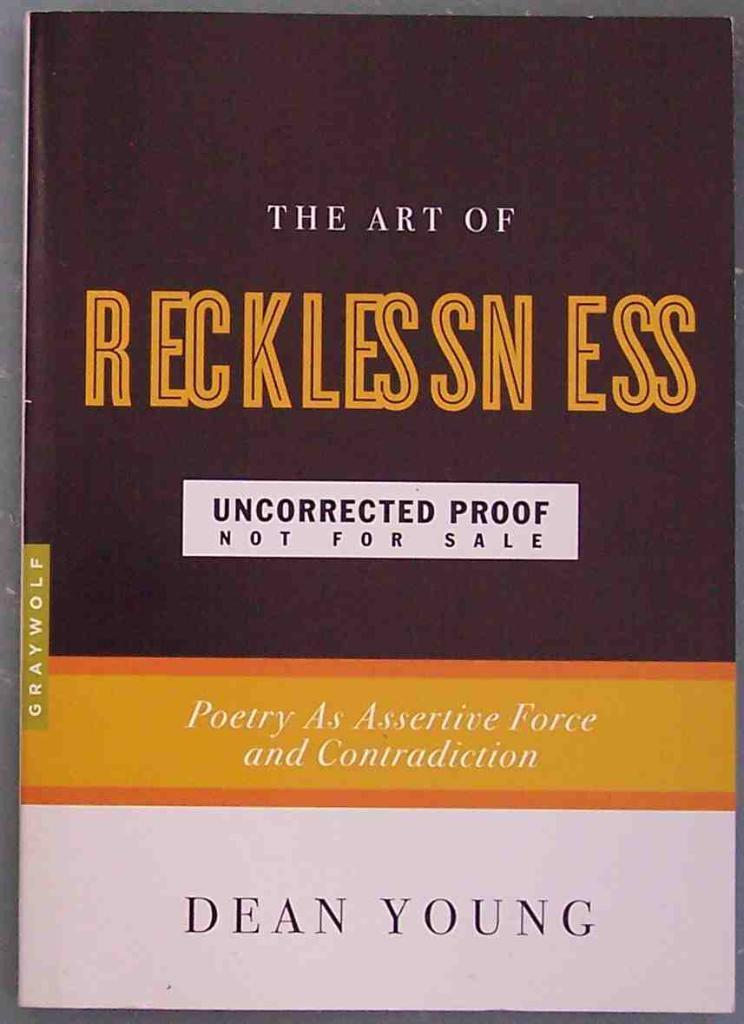<image>
Create a compact narrative representing the image presented. A book by Dean Young called The Art of Recklessness. 